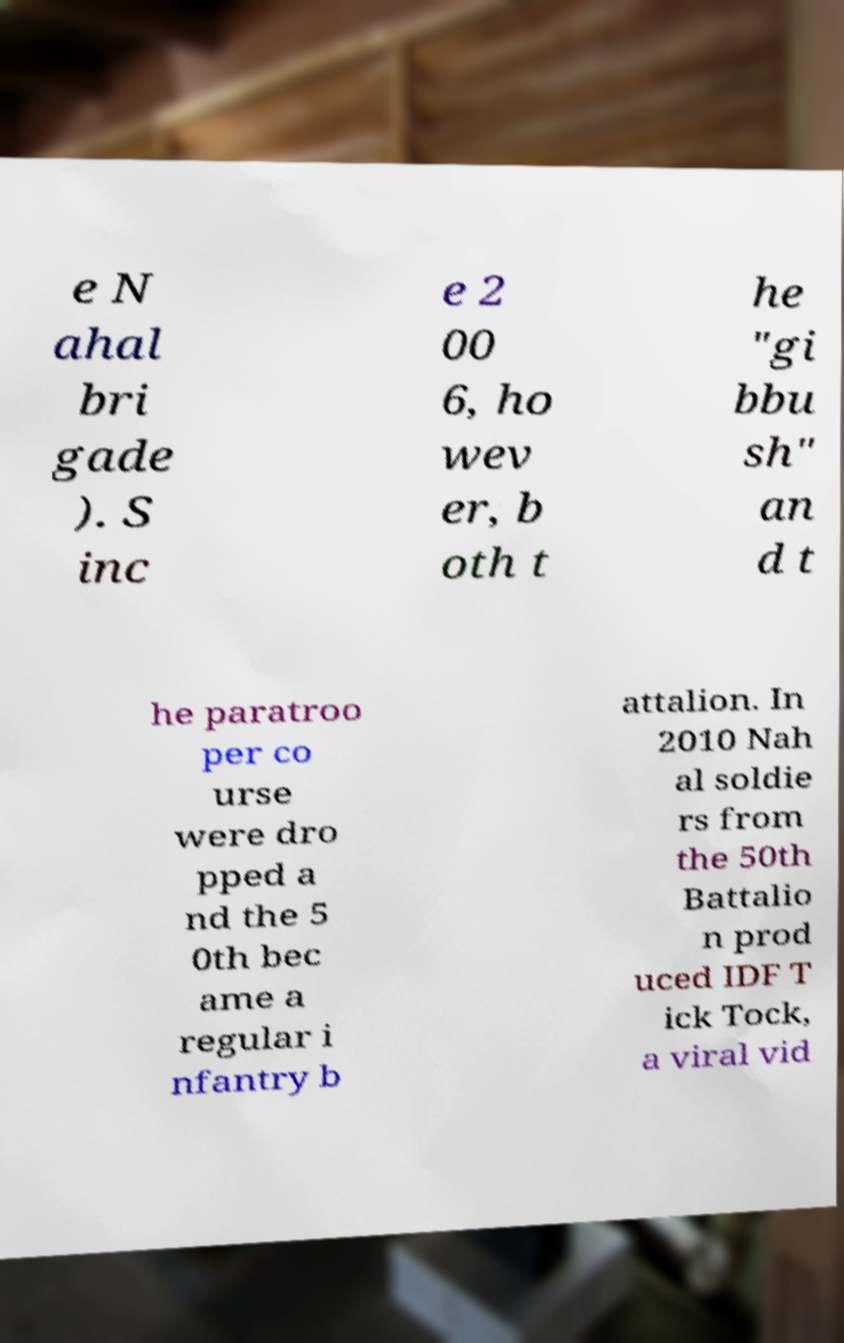Can you read and provide the text displayed in the image?This photo seems to have some interesting text. Can you extract and type it out for me? e N ahal bri gade ). S inc e 2 00 6, ho wev er, b oth t he "gi bbu sh" an d t he paratroo per co urse were dro pped a nd the 5 0th bec ame a regular i nfantry b attalion. In 2010 Nah al soldie rs from the 50th Battalio n prod uced IDF T ick Tock, a viral vid 